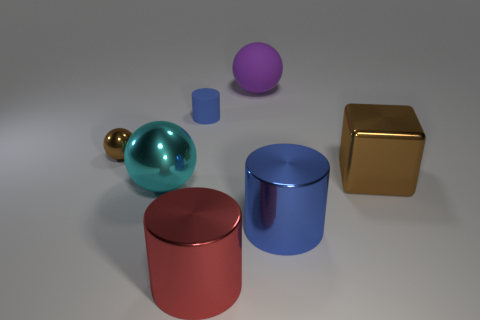Does the big blue thing have the same material as the big purple thing?
Your answer should be very brief. No. How many other things are the same shape as the large brown thing?
Your response must be concise. 0. What size is the sphere that is to the right of the brown sphere and in front of the large matte thing?
Give a very brief answer. Large. What number of matte objects are brown objects or gray cylinders?
Your answer should be compact. 0. Is the shape of the large metallic thing that is on the right side of the big blue metallic object the same as the blue thing that is in front of the tiny brown thing?
Your response must be concise. No. Is there a small green block made of the same material as the small cylinder?
Your response must be concise. No. What is the color of the tiny metal thing?
Give a very brief answer. Brown. How big is the metal sphere that is in front of the tiny metal ball?
Ensure brevity in your answer.  Large. How many tiny cylinders are the same color as the small metal thing?
Give a very brief answer. 0. Are there any big brown shiny cubes behind the cylinder that is behind the small brown metal thing?
Your response must be concise. No. 